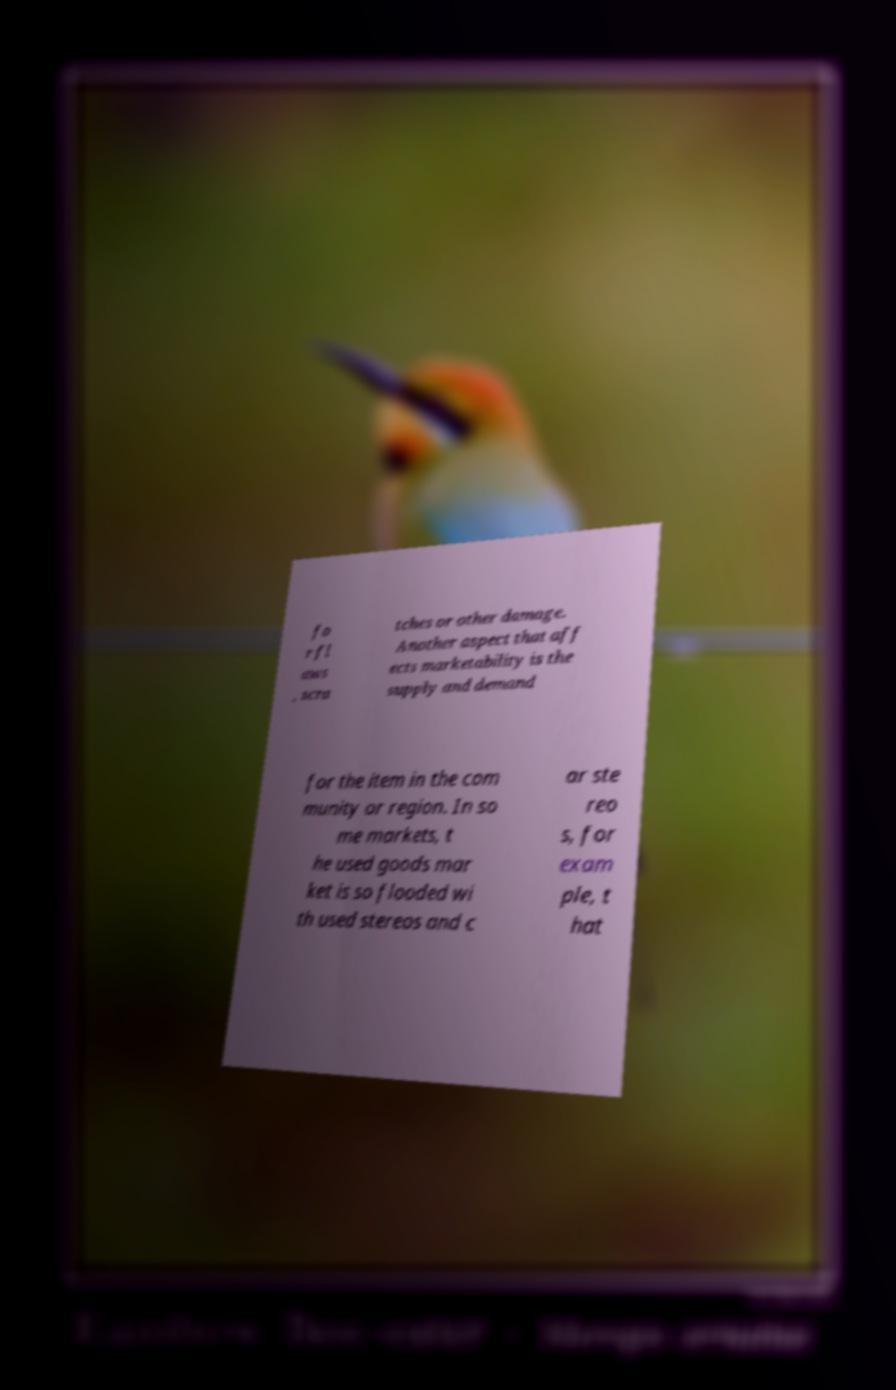What messages or text are displayed in this image? I need them in a readable, typed format. fo r fl aws , scra tches or other damage. Another aspect that aff ects marketability is the supply and demand for the item in the com munity or region. In so me markets, t he used goods mar ket is so flooded wi th used stereos and c ar ste reo s, for exam ple, t hat 